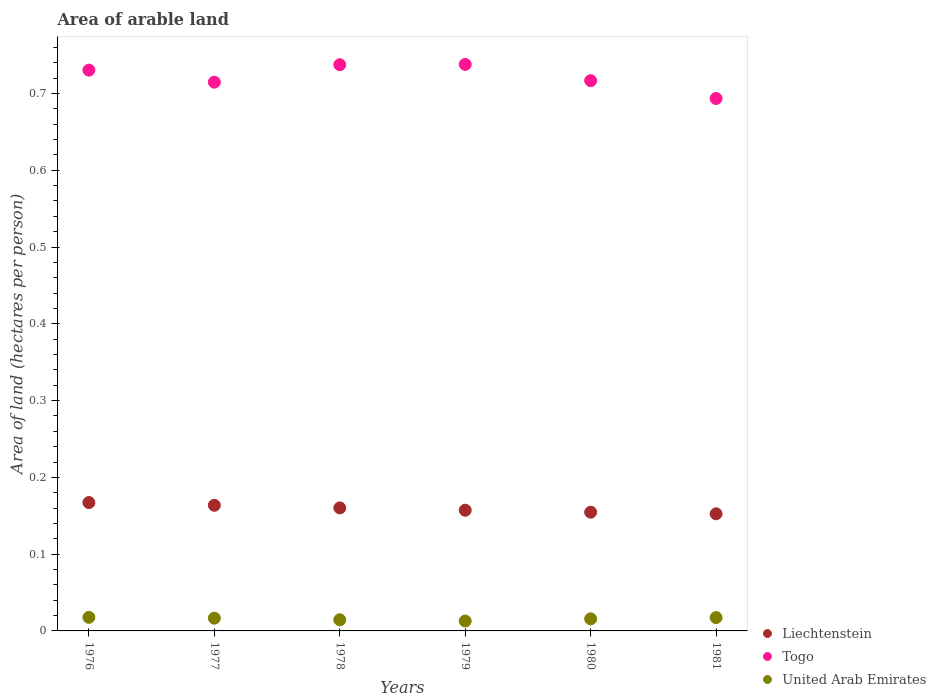What is the total arable land in Togo in 1980?
Your response must be concise. 0.72. Across all years, what is the maximum total arable land in Togo?
Provide a succinct answer. 0.74. Across all years, what is the minimum total arable land in United Arab Emirates?
Provide a short and direct response. 0.01. In which year was the total arable land in United Arab Emirates maximum?
Your answer should be compact. 1976. In which year was the total arable land in United Arab Emirates minimum?
Provide a short and direct response. 1979. What is the total total arable land in Liechtenstein in the graph?
Give a very brief answer. 0.96. What is the difference between the total arable land in Liechtenstein in 1976 and that in 1981?
Keep it short and to the point. 0.01. What is the difference between the total arable land in Liechtenstein in 1976 and the total arable land in United Arab Emirates in 1977?
Ensure brevity in your answer.  0.15. What is the average total arable land in Togo per year?
Make the answer very short. 0.72. In the year 1981, what is the difference between the total arable land in United Arab Emirates and total arable land in Liechtenstein?
Offer a terse response. -0.14. What is the ratio of the total arable land in Liechtenstein in 1977 to that in 1979?
Give a very brief answer. 1.04. Is the difference between the total arable land in United Arab Emirates in 1978 and 1980 greater than the difference between the total arable land in Liechtenstein in 1978 and 1980?
Offer a terse response. No. What is the difference between the highest and the second highest total arable land in Togo?
Offer a very short reply. 0. What is the difference between the highest and the lowest total arable land in Togo?
Give a very brief answer. 0.04. In how many years, is the total arable land in United Arab Emirates greater than the average total arable land in United Arab Emirates taken over all years?
Provide a short and direct response. 3. Is the sum of the total arable land in Liechtenstein in 1977 and 1978 greater than the maximum total arable land in Togo across all years?
Ensure brevity in your answer.  No. Does the total arable land in Liechtenstein monotonically increase over the years?
Ensure brevity in your answer.  No. Is the total arable land in Liechtenstein strictly greater than the total arable land in United Arab Emirates over the years?
Provide a short and direct response. Yes. How many years are there in the graph?
Your answer should be compact. 6. Does the graph contain any zero values?
Your response must be concise. No. How many legend labels are there?
Your answer should be compact. 3. What is the title of the graph?
Your response must be concise. Area of arable land. Does "Tuvalu" appear as one of the legend labels in the graph?
Provide a short and direct response. No. What is the label or title of the X-axis?
Your answer should be compact. Years. What is the label or title of the Y-axis?
Your answer should be compact. Area of land (hectares per person). What is the Area of land (hectares per person) of Liechtenstein in 1976?
Your response must be concise. 0.17. What is the Area of land (hectares per person) in Togo in 1976?
Make the answer very short. 0.73. What is the Area of land (hectares per person) of United Arab Emirates in 1976?
Offer a very short reply. 0.02. What is the Area of land (hectares per person) in Liechtenstein in 1977?
Your answer should be compact. 0.16. What is the Area of land (hectares per person) in Togo in 1977?
Offer a very short reply. 0.71. What is the Area of land (hectares per person) in United Arab Emirates in 1977?
Ensure brevity in your answer.  0.02. What is the Area of land (hectares per person) of Liechtenstein in 1978?
Your answer should be compact. 0.16. What is the Area of land (hectares per person) in Togo in 1978?
Offer a terse response. 0.74. What is the Area of land (hectares per person) in United Arab Emirates in 1978?
Give a very brief answer. 0.01. What is the Area of land (hectares per person) of Liechtenstein in 1979?
Provide a succinct answer. 0.16. What is the Area of land (hectares per person) of Togo in 1979?
Your answer should be very brief. 0.74. What is the Area of land (hectares per person) of United Arab Emirates in 1979?
Your response must be concise. 0.01. What is the Area of land (hectares per person) of Liechtenstein in 1980?
Keep it short and to the point. 0.15. What is the Area of land (hectares per person) of Togo in 1980?
Your answer should be very brief. 0.72. What is the Area of land (hectares per person) in United Arab Emirates in 1980?
Provide a succinct answer. 0.02. What is the Area of land (hectares per person) in Liechtenstein in 1981?
Provide a short and direct response. 0.15. What is the Area of land (hectares per person) of Togo in 1981?
Offer a very short reply. 0.69. What is the Area of land (hectares per person) of United Arab Emirates in 1981?
Offer a very short reply. 0.02. Across all years, what is the maximum Area of land (hectares per person) in Liechtenstein?
Your answer should be compact. 0.17. Across all years, what is the maximum Area of land (hectares per person) in Togo?
Your answer should be very brief. 0.74. Across all years, what is the maximum Area of land (hectares per person) of United Arab Emirates?
Your response must be concise. 0.02. Across all years, what is the minimum Area of land (hectares per person) in Liechtenstein?
Give a very brief answer. 0.15. Across all years, what is the minimum Area of land (hectares per person) of Togo?
Provide a succinct answer. 0.69. Across all years, what is the minimum Area of land (hectares per person) of United Arab Emirates?
Your answer should be compact. 0.01. What is the total Area of land (hectares per person) in Liechtenstein in the graph?
Offer a terse response. 0.96. What is the total Area of land (hectares per person) in Togo in the graph?
Provide a short and direct response. 4.33. What is the total Area of land (hectares per person) in United Arab Emirates in the graph?
Ensure brevity in your answer.  0.09. What is the difference between the Area of land (hectares per person) in Liechtenstein in 1976 and that in 1977?
Ensure brevity in your answer.  0. What is the difference between the Area of land (hectares per person) in Togo in 1976 and that in 1977?
Offer a terse response. 0.02. What is the difference between the Area of land (hectares per person) of United Arab Emirates in 1976 and that in 1977?
Make the answer very short. 0. What is the difference between the Area of land (hectares per person) in Liechtenstein in 1976 and that in 1978?
Offer a very short reply. 0.01. What is the difference between the Area of land (hectares per person) in Togo in 1976 and that in 1978?
Offer a very short reply. -0.01. What is the difference between the Area of land (hectares per person) of United Arab Emirates in 1976 and that in 1978?
Your response must be concise. 0. What is the difference between the Area of land (hectares per person) of Togo in 1976 and that in 1979?
Your response must be concise. -0.01. What is the difference between the Area of land (hectares per person) of United Arab Emirates in 1976 and that in 1979?
Provide a short and direct response. 0. What is the difference between the Area of land (hectares per person) in Liechtenstein in 1976 and that in 1980?
Keep it short and to the point. 0.01. What is the difference between the Area of land (hectares per person) in Togo in 1976 and that in 1980?
Give a very brief answer. 0.01. What is the difference between the Area of land (hectares per person) in United Arab Emirates in 1976 and that in 1980?
Your answer should be very brief. 0. What is the difference between the Area of land (hectares per person) in Liechtenstein in 1976 and that in 1981?
Provide a short and direct response. 0.01. What is the difference between the Area of land (hectares per person) of Togo in 1976 and that in 1981?
Give a very brief answer. 0.04. What is the difference between the Area of land (hectares per person) of Liechtenstein in 1977 and that in 1978?
Provide a succinct answer. 0. What is the difference between the Area of land (hectares per person) of Togo in 1977 and that in 1978?
Make the answer very short. -0.02. What is the difference between the Area of land (hectares per person) in United Arab Emirates in 1977 and that in 1978?
Provide a succinct answer. 0. What is the difference between the Area of land (hectares per person) of Liechtenstein in 1977 and that in 1979?
Ensure brevity in your answer.  0.01. What is the difference between the Area of land (hectares per person) in Togo in 1977 and that in 1979?
Your answer should be very brief. -0.02. What is the difference between the Area of land (hectares per person) of United Arab Emirates in 1977 and that in 1979?
Give a very brief answer. 0. What is the difference between the Area of land (hectares per person) of Liechtenstein in 1977 and that in 1980?
Ensure brevity in your answer.  0.01. What is the difference between the Area of land (hectares per person) of Togo in 1977 and that in 1980?
Provide a short and direct response. -0. What is the difference between the Area of land (hectares per person) in United Arab Emirates in 1977 and that in 1980?
Ensure brevity in your answer.  0. What is the difference between the Area of land (hectares per person) in Liechtenstein in 1977 and that in 1981?
Keep it short and to the point. 0.01. What is the difference between the Area of land (hectares per person) in Togo in 1977 and that in 1981?
Provide a succinct answer. 0.02. What is the difference between the Area of land (hectares per person) in United Arab Emirates in 1977 and that in 1981?
Provide a short and direct response. -0. What is the difference between the Area of land (hectares per person) of Liechtenstein in 1978 and that in 1979?
Your answer should be very brief. 0. What is the difference between the Area of land (hectares per person) in Togo in 1978 and that in 1979?
Provide a succinct answer. -0. What is the difference between the Area of land (hectares per person) of United Arab Emirates in 1978 and that in 1979?
Provide a short and direct response. 0. What is the difference between the Area of land (hectares per person) in Liechtenstein in 1978 and that in 1980?
Provide a succinct answer. 0.01. What is the difference between the Area of land (hectares per person) of Togo in 1978 and that in 1980?
Give a very brief answer. 0.02. What is the difference between the Area of land (hectares per person) in United Arab Emirates in 1978 and that in 1980?
Provide a succinct answer. -0. What is the difference between the Area of land (hectares per person) of Liechtenstein in 1978 and that in 1981?
Provide a short and direct response. 0.01. What is the difference between the Area of land (hectares per person) of Togo in 1978 and that in 1981?
Keep it short and to the point. 0.04. What is the difference between the Area of land (hectares per person) of United Arab Emirates in 1978 and that in 1981?
Your answer should be very brief. -0. What is the difference between the Area of land (hectares per person) in Liechtenstein in 1979 and that in 1980?
Make the answer very short. 0. What is the difference between the Area of land (hectares per person) of Togo in 1979 and that in 1980?
Provide a short and direct response. 0.02. What is the difference between the Area of land (hectares per person) in United Arab Emirates in 1979 and that in 1980?
Provide a short and direct response. -0. What is the difference between the Area of land (hectares per person) in Liechtenstein in 1979 and that in 1981?
Offer a terse response. 0. What is the difference between the Area of land (hectares per person) of Togo in 1979 and that in 1981?
Ensure brevity in your answer.  0.04. What is the difference between the Area of land (hectares per person) in United Arab Emirates in 1979 and that in 1981?
Provide a short and direct response. -0. What is the difference between the Area of land (hectares per person) of Liechtenstein in 1980 and that in 1981?
Keep it short and to the point. 0. What is the difference between the Area of land (hectares per person) in Togo in 1980 and that in 1981?
Your answer should be compact. 0.02. What is the difference between the Area of land (hectares per person) of United Arab Emirates in 1980 and that in 1981?
Your response must be concise. -0. What is the difference between the Area of land (hectares per person) in Liechtenstein in 1976 and the Area of land (hectares per person) in Togo in 1977?
Your response must be concise. -0.55. What is the difference between the Area of land (hectares per person) of Liechtenstein in 1976 and the Area of land (hectares per person) of United Arab Emirates in 1977?
Provide a succinct answer. 0.15. What is the difference between the Area of land (hectares per person) in Togo in 1976 and the Area of land (hectares per person) in United Arab Emirates in 1977?
Your response must be concise. 0.71. What is the difference between the Area of land (hectares per person) in Liechtenstein in 1976 and the Area of land (hectares per person) in Togo in 1978?
Provide a succinct answer. -0.57. What is the difference between the Area of land (hectares per person) in Liechtenstein in 1976 and the Area of land (hectares per person) in United Arab Emirates in 1978?
Ensure brevity in your answer.  0.15. What is the difference between the Area of land (hectares per person) in Togo in 1976 and the Area of land (hectares per person) in United Arab Emirates in 1978?
Your answer should be compact. 0.72. What is the difference between the Area of land (hectares per person) in Liechtenstein in 1976 and the Area of land (hectares per person) in Togo in 1979?
Offer a terse response. -0.57. What is the difference between the Area of land (hectares per person) of Liechtenstein in 1976 and the Area of land (hectares per person) of United Arab Emirates in 1979?
Provide a short and direct response. 0.15. What is the difference between the Area of land (hectares per person) of Togo in 1976 and the Area of land (hectares per person) of United Arab Emirates in 1979?
Provide a short and direct response. 0.72. What is the difference between the Area of land (hectares per person) in Liechtenstein in 1976 and the Area of land (hectares per person) in Togo in 1980?
Keep it short and to the point. -0.55. What is the difference between the Area of land (hectares per person) of Liechtenstein in 1976 and the Area of land (hectares per person) of United Arab Emirates in 1980?
Your answer should be compact. 0.15. What is the difference between the Area of land (hectares per person) of Togo in 1976 and the Area of land (hectares per person) of United Arab Emirates in 1980?
Ensure brevity in your answer.  0.71. What is the difference between the Area of land (hectares per person) of Liechtenstein in 1976 and the Area of land (hectares per person) of Togo in 1981?
Provide a succinct answer. -0.53. What is the difference between the Area of land (hectares per person) in Liechtenstein in 1976 and the Area of land (hectares per person) in United Arab Emirates in 1981?
Your answer should be very brief. 0.15. What is the difference between the Area of land (hectares per person) in Togo in 1976 and the Area of land (hectares per person) in United Arab Emirates in 1981?
Provide a short and direct response. 0.71. What is the difference between the Area of land (hectares per person) of Liechtenstein in 1977 and the Area of land (hectares per person) of Togo in 1978?
Keep it short and to the point. -0.57. What is the difference between the Area of land (hectares per person) in Liechtenstein in 1977 and the Area of land (hectares per person) in United Arab Emirates in 1978?
Your response must be concise. 0.15. What is the difference between the Area of land (hectares per person) of Togo in 1977 and the Area of land (hectares per person) of United Arab Emirates in 1978?
Your response must be concise. 0.7. What is the difference between the Area of land (hectares per person) in Liechtenstein in 1977 and the Area of land (hectares per person) in Togo in 1979?
Provide a succinct answer. -0.57. What is the difference between the Area of land (hectares per person) of Liechtenstein in 1977 and the Area of land (hectares per person) of United Arab Emirates in 1979?
Your answer should be very brief. 0.15. What is the difference between the Area of land (hectares per person) in Togo in 1977 and the Area of land (hectares per person) in United Arab Emirates in 1979?
Keep it short and to the point. 0.7. What is the difference between the Area of land (hectares per person) of Liechtenstein in 1977 and the Area of land (hectares per person) of Togo in 1980?
Provide a short and direct response. -0.55. What is the difference between the Area of land (hectares per person) of Liechtenstein in 1977 and the Area of land (hectares per person) of United Arab Emirates in 1980?
Give a very brief answer. 0.15. What is the difference between the Area of land (hectares per person) of Togo in 1977 and the Area of land (hectares per person) of United Arab Emirates in 1980?
Your answer should be very brief. 0.7. What is the difference between the Area of land (hectares per person) of Liechtenstein in 1977 and the Area of land (hectares per person) of Togo in 1981?
Your response must be concise. -0.53. What is the difference between the Area of land (hectares per person) in Liechtenstein in 1977 and the Area of land (hectares per person) in United Arab Emirates in 1981?
Provide a short and direct response. 0.15. What is the difference between the Area of land (hectares per person) in Togo in 1977 and the Area of land (hectares per person) in United Arab Emirates in 1981?
Your response must be concise. 0.7. What is the difference between the Area of land (hectares per person) of Liechtenstein in 1978 and the Area of land (hectares per person) of Togo in 1979?
Your answer should be compact. -0.58. What is the difference between the Area of land (hectares per person) of Liechtenstein in 1978 and the Area of land (hectares per person) of United Arab Emirates in 1979?
Provide a short and direct response. 0.15. What is the difference between the Area of land (hectares per person) of Togo in 1978 and the Area of land (hectares per person) of United Arab Emirates in 1979?
Give a very brief answer. 0.72. What is the difference between the Area of land (hectares per person) in Liechtenstein in 1978 and the Area of land (hectares per person) in Togo in 1980?
Your response must be concise. -0.56. What is the difference between the Area of land (hectares per person) in Liechtenstein in 1978 and the Area of land (hectares per person) in United Arab Emirates in 1980?
Make the answer very short. 0.14. What is the difference between the Area of land (hectares per person) in Togo in 1978 and the Area of land (hectares per person) in United Arab Emirates in 1980?
Your response must be concise. 0.72. What is the difference between the Area of land (hectares per person) of Liechtenstein in 1978 and the Area of land (hectares per person) of Togo in 1981?
Provide a succinct answer. -0.53. What is the difference between the Area of land (hectares per person) of Liechtenstein in 1978 and the Area of land (hectares per person) of United Arab Emirates in 1981?
Offer a very short reply. 0.14. What is the difference between the Area of land (hectares per person) in Togo in 1978 and the Area of land (hectares per person) in United Arab Emirates in 1981?
Provide a succinct answer. 0.72. What is the difference between the Area of land (hectares per person) in Liechtenstein in 1979 and the Area of land (hectares per person) in Togo in 1980?
Provide a succinct answer. -0.56. What is the difference between the Area of land (hectares per person) of Liechtenstein in 1979 and the Area of land (hectares per person) of United Arab Emirates in 1980?
Ensure brevity in your answer.  0.14. What is the difference between the Area of land (hectares per person) in Togo in 1979 and the Area of land (hectares per person) in United Arab Emirates in 1980?
Your answer should be very brief. 0.72. What is the difference between the Area of land (hectares per person) of Liechtenstein in 1979 and the Area of land (hectares per person) of Togo in 1981?
Make the answer very short. -0.54. What is the difference between the Area of land (hectares per person) of Liechtenstein in 1979 and the Area of land (hectares per person) of United Arab Emirates in 1981?
Provide a succinct answer. 0.14. What is the difference between the Area of land (hectares per person) in Togo in 1979 and the Area of land (hectares per person) in United Arab Emirates in 1981?
Ensure brevity in your answer.  0.72. What is the difference between the Area of land (hectares per person) of Liechtenstein in 1980 and the Area of land (hectares per person) of Togo in 1981?
Make the answer very short. -0.54. What is the difference between the Area of land (hectares per person) of Liechtenstein in 1980 and the Area of land (hectares per person) of United Arab Emirates in 1981?
Keep it short and to the point. 0.14. What is the difference between the Area of land (hectares per person) of Togo in 1980 and the Area of land (hectares per person) of United Arab Emirates in 1981?
Keep it short and to the point. 0.7. What is the average Area of land (hectares per person) in Liechtenstein per year?
Provide a short and direct response. 0.16. What is the average Area of land (hectares per person) of Togo per year?
Offer a very short reply. 0.72. What is the average Area of land (hectares per person) in United Arab Emirates per year?
Your answer should be compact. 0.02. In the year 1976, what is the difference between the Area of land (hectares per person) of Liechtenstein and Area of land (hectares per person) of Togo?
Offer a terse response. -0.56. In the year 1976, what is the difference between the Area of land (hectares per person) in Liechtenstein and Area of land (hectares per person) in United Arab Emirates?
Offer a terse response. 0.15. In the year 1976, what is the difference between the Area of land (hectares per person) in Togo and Area of land (hectares per person) in United Arab Emirates?
Provide a succinct answer. 0.71. In the year 1977, what is the difference between the Area of land (hectares per person) in Liechtenstein and Area of land (hectares per person) in Togo?
Provide a short and direct response. -0.55. In the year 1977, what is the difference between the Area of land (hectares per person) of Liechtenstein and Area of land (hectares per person) of United Arab Emirates?
Your answer should be compact. 0.15. In the year 1977, what is the difference between the Area of land (hectares per person) of Togo and Area of land (hectares per person) of United Arab Emirates?
Give a very brief answer. 0.7. In the year 1978, what is the difference between the Area of land (hectares per person) of Liechtenstein and Area of land (hectares per person) of Togo?
Give a very brief answer. -0.58. In the year 1978, what is the difference between the Area of land (hectares per person) in Liechtenstein and Area of land (hectares per person) in United Arab Emirates?
Your answer should be compact. 0.15. In the year 1978, what is the difference between the Area of land (hectares per person) in Togo and Area of land (hectares per person) in United Arab Emirates?
Offer a very short reply. 0.72. In the year 1979, what is the difference between the Area of land (hectares per person) of Liechtenstein and Area of land (hectares per person) of Togo?
Your answer should be compact. -0.58. In the year 1979, what is the difference between the Area of land (hectares per person) of Liechtenstein and Area of land (hectares per person) of United Arab Emirates?
Make the answer very short. 0.14. In the year 1979, what is the difference between the Area of land (hectares per person) of Togo and Area of land (hectares per person) of United Arab Emirates?
Provide a short and direct response. 0.72. In the year 1980, what is the difference between the Area of land (hectares per person) in Liechtenstein and Area of land (hectares per person) in Togo?
Ensure brevity in your answer.  -0.56. In the year 1980, what is the difference between the Area of land (hectares per person) of Liechtenstein and Area of land (hectares per person) of United Arab Emirates?
Offer a very short reply. 0.14. In the year 1980, what is the difference between the Area of land (hectares per person) of Togo and Area of land (hectares per person) of United Arab Emirates?
Ensure brevity in your answer.  0.7. In the year 1981, what is the difference between the Area of land (hectares per person) in Liechtenstein and Area of land (hectares per person) in Togo?
Keep it short and to the point. -0.54. In the year 1981, what is the difference between the Area of land (hectares per person) in Liechtenstein and Area of land (hectares per person) in United Arab Emirates?
Offer a very short reply. 0.14. In the year 1981, what is the difference between the Area of land (hectares per person) in Togo and Area of land (hectares per person) in United Arab Emirates?
Give a very brief answer. 0.68. What is the ratio of the Area of land (hectares per person) of Liechtenstein in 1976 to that in 1977?
Your answer should be compact. 1.02. What is the ratio of the Area of land (hectares per person) in Togo in 1976 to that in 1977?
Your response must be concise. 1.02. What is the ratio of the Area of land (hectares per person) in United Arab Emirates in 1976 to that in 1977?
Provide a succinct answer. 1.07. What is the ratio of the Area of land (hectares per person) in Liechtenstein in 1976 to that in 1978?
Give a very brief answer. 1.04. What is the ratio of the Area of land (hectares per person) in United Arab Emirates in 1976 to that in 1978?
Your response must be concise. 1.22. What is the ratio of the Area of land (hectares per person) of Liechtenstein in 1976 to that in 1979?
Give a very brief answer. 1.06. What is the ratio of the Area of land (hectares per person) in Togo in 1976 to that in 1979?
Offer a terse response. 0.99. What is the ratio of the Area of land (hectares per person) in United Arab Emirates in 1976 to that in 1979?
Your answer should be compact. 1.37. What is the ratio of the Area of land (hectares per person) of Liechtenstein in 1976 to that in 1980?
Keep it short and to the point. 1.08. What is the ratio of the Area of land (hectares per person) in Togo in 1976 to that in 1980?
Keep it short and to the point. 1.02. What is the ratio of the Area of land (hectares per person) in United Arab Emirates in 1976 to that in 1980?
Offer a very short reply. 1.12. What is the ratio of the Area of land (hectares per person) in Liechtenstein in 1976 to that in 1981?
Provide a short and direct response. 1.1. What is the ratio of the Area of land (hectares per person) of Togo in 1976 to that in 1981?
Make the answer very short. 1.05. What is the ratio of the Area of land (hectares per person) in United Arab Emirates in 1976 to that in 1981?
Provide a short and direct response. 1.02. What is the ratio of the Area of land (hectares per person) in Liechtenstein in 1977 to that in 1978?
Offer a very short reply. 1.02. What is the ratio of the Area of land (hectares per person) in Togo in 1977 to that in 1978?
Provide a succinct answer. 0.97. What is the ratio of the Area of land (hectares per person) of United Arab Emirates in 1977 to that in 1978?
Your answer should be compact. 1.14. What is the ratio of the Area of land (hectares per person) in Liechtenstein in 1977 to that in 1979?
Provide a succinct answer. 1.04. What is the ratio of the Area of land (hectares per person) in Togo in 1977 to that in 1979?
Make the answer very short. 0.97. What is the ratio of the Area of land (hectares per person) of United Arab Emirates in 1977 to that in 1979?
Your answer should be very brief. 1.28. What is the ratio of the Area of land (hectares per person) of Liechtenstein in 1977 to that in 1980?
Offer a terse response. 1.06. What is the ratio of the Area of land (hectares per person) of United Arab Emirates in 1977 to that in 1980?
Ensure brevity in your answer.  1.05. What is the ratio of the Area of land (hectares per person) in Liechtenstein in 1977 to that in 1981?
Make the answer very short. 1.07. What is the ratio of the Area of land (hectares per person) of Togo in 1977 to that in 1981?
Provide a succinct answer. 1.03. What is the ratio of the Area of land (hectares per person) of United Arab Emirates in 1977 to that in 1981?
Give a very brief answer. 0.96. What is the ratio of the Area of land (hectares per person) in Liechtenstein in 1978 to that in 1979?
Offer a very short reply. 1.02. What is the ratio of the Area of land (hectares per person) of United Arab Emirates in 1978 to that in 1979?
Offer a terse response. 1.12. What is the ratio of the Area of land (hectares per person) of Liechtenstein in 1978 to that in 1980?
Your answer should be compact. 1.04. What is the ratio of the Area of land (hectares per person) of United Arab Emirates in 1978 to that in 1980?
Offer a terse response. 0.92. What is the ratio of the Area of land (hectares per person) of Liechtenstein in 1978 to that in 1981?
Make the answer very short. 1.05. What is the ratio of the Area of land (hectares per person) of Togo in 1978 to that in 1981?
Give a very brief answer. 1.06. What is the ratio of the Area of land (hectares per person) of United Arab Emirates in 1978 to that in 1981?
Your answer should be very brief. 0.83. What is the ratio of the Area of land (hectares per person) of Liechtenstein in 1979 to that in 1980?
Your answer should be compact. 1.02. What is the ratio of the Area of land (hectares per person) of Togo in 1979 to that in 1980?
Ensure brevity in your answer.  1.03. What is the ratio of the Area of land (hectares per person) of United Arab Emirates in 1979 to that in 1980?
Give a very brief answer. 0.82. What is the ratio of the Area of land (hectares per person) in Liechtenstein in 1979 to that in 1981?
Provide a short and direct response. 1.03. What is the ratio of the Area of land (hectares per person) of Togo in 1979 to that in 1981?
Your response must be concise. 1.06. What is the ratio of the Area of land (hectares per person) of United Arab Emirates in 1979 to that in 1981?
Ensure brevity in your answer.  0.74. What is the ratio of the Area of land (hectares per person) of Liechtenstein in 1980 to that in 1981?
Provide a succinct answer. 1.01. What is the ratio of the Area of land (hectares per person) of Togo in 1980 to that in 1981?
Provide a short and direct response. 1.03. What is the ratio of the Area of land (hectares per person) of United Arab Emirates in 1980 to that in 1981?
Your answer should be very brief. 0.91. What is the difference between the highest and the second highest Area of land (hectares per person) of Liechtenstein?
Offer a very short reply. 0. What is the difference between the highest and the lowest Area of land (hectares per person) in Liechtenstein?
Your answer should be very brief. 0.01. What is the difference between the highest and the lowest Area of land (hectares per person) of Togo?
Give a very brief answer. 0.04. What is the difference between the highest and the lowest Area of land (hectares per person) of United Arab Emirates?
Offer a terse response. 0. 